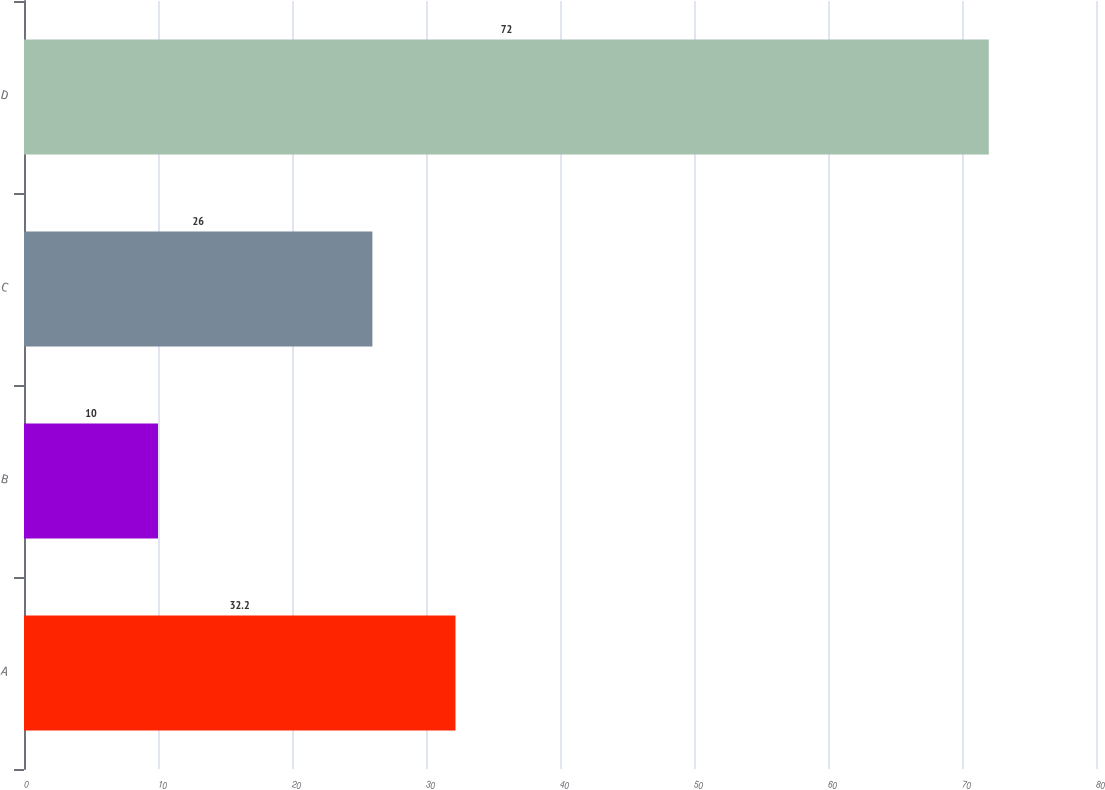Convert chart to OTSL. <chart><loc_0><loc_0><loc_500><loc_500><bar_chart><fcel>A<fcel>B<fcel>C<fcel>D<nl><fcel>32.2<fcel>10<fcel>26<fcel>72<nl></chart> 